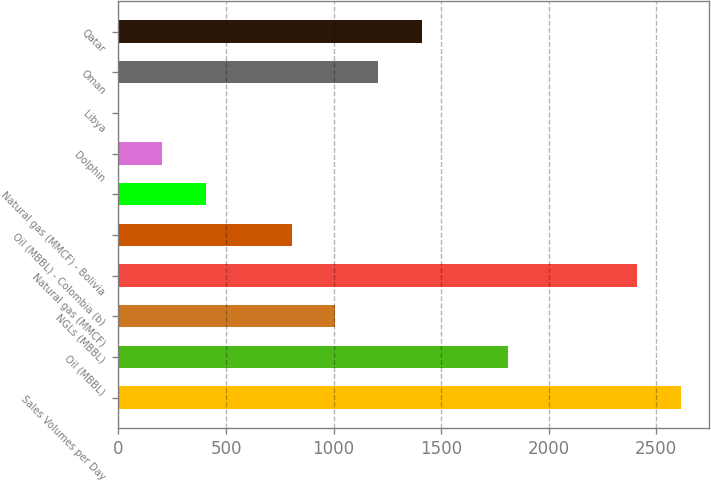<chart> <loc_0><loc_0><loc_500><loc_500><bar_chart><fcel>Sales Volumes per Day<fcel>Oil (MBBL)<fcel>NGLs (MBBL)<fcel>Natural gas (MMCF)<fcel>Oil (MBBL) - Colombia (b)<fcel>Natural gas (MMCF) - Bolivia<fcel>Dolphin<fcel>Libya<fcel>Oman<fcel>Qatar<nl><fcel>2613.1<fcel>1810.3<fcel>1007.5<fcel>2412.4<fcel>806.8<fcel>405.4<fcel>204.7<fcel>4<fcel>1208.2<fcel>1408.9<nl></chart> 